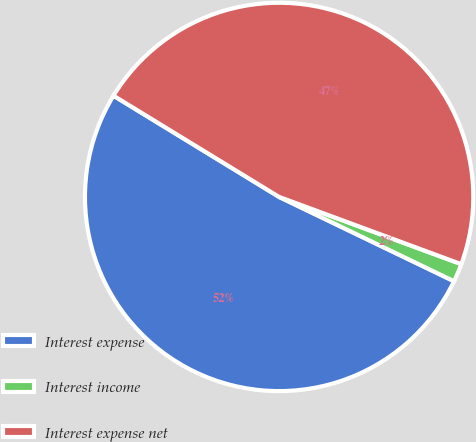Convert chart to OTSL. <chart><loc_0><loc_0><loc_500><loc_500><pie_chart><fcel>Interest expense<fcel>Interest income<fcel>Interest expense net<nl><fcel>51.59%<fcel>1.52%<fcel>46.9%<nl></chart> 